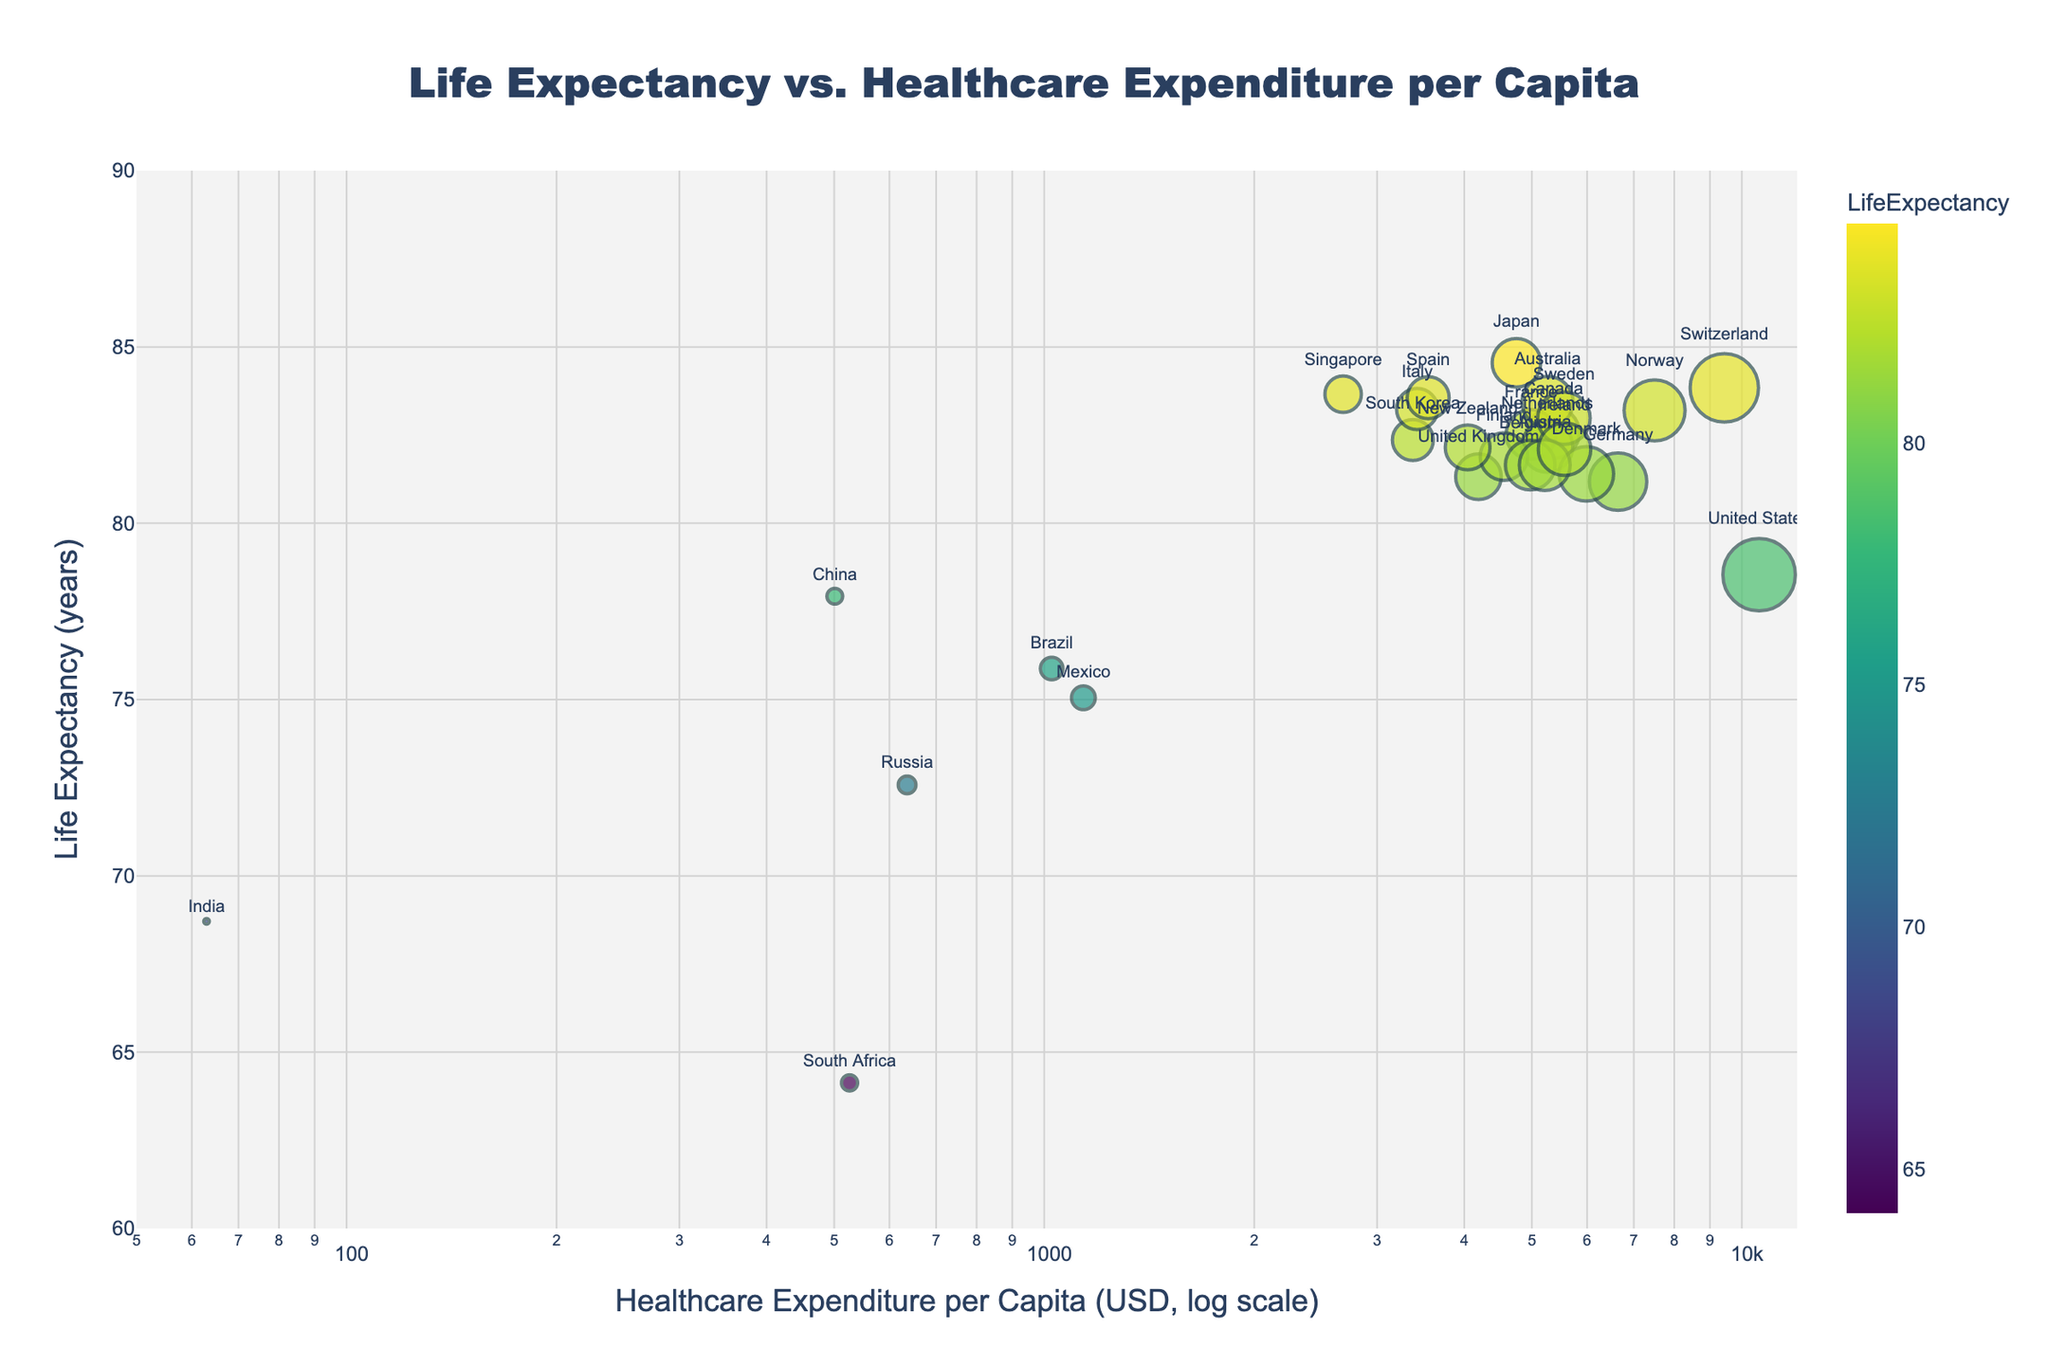what is the title of the scatter plot? The title of a plot is usually found at the top and it summarizes what the graph is about. Looking at the top of the scatter plot, the title reads "Life Expectancy vs. Healthcare Expenditure per Capita"
Answer: Life Expectancy vs. Healthcare Expenditure per Capita How many countries have a life expectancy above 80 years? To answer this, we need to count the number of data points (bubbles) on the scatter plot where the y-axis value (life expectancy) is above 80. By observation, there are 21 countries with life expectancy above 80 years.
Answer: 21 Which country has the highest healthcare expenditure per capita? To answer this, we need to look for the right-most data point (bubble) since the x-axis represents healthcare expenditure per capita on a log scale. The United States is the right-most point, indicating it has the highest healthcare expenditure per capita.
Answer: United States Among countries with healthcare expenditure per capita less than $1,000, which country has the highest life expectancy? First, locate the data points to the left of $1,000 on the x-axis (healthcare expenditure per capita). Among these points, identify the one with the highest y-axis value (life expectancy). South Africa, with a healthcare expenditure per capita of $526 and a life expectancy of 64.13, stands out in this range.
Answer: South Africa What is the difference in life expectancy between Japan and the United States? To find the difference, subtract the life expectancy of the United States from that of Japan. Japan's life expectancy is 84.55 years, and the United States' life expectancy is 78.54 years. 84.55 - 78.54 = 6.01 years.
Answer: 6.01 years Do higher healthcare expenditures always correlate to higher life expectancies? Give an example to support your answer. Generally, higher healthcare expenditures tend to correlate with higher life expectancies, but there are exceptions. For instance, the United States spends the most on healthcare per capita yet only has a life expectancy of 78.54 years, whereas Japan has a life expectancy of 84.55 years with significantly lower expenditure.
Answer: No, for example, the United States and Japan Which country has the lowest healthcare expenditure per capita, and what is its life expectancy? Look for the left-most data point (bubble) on the scatter plot because the x-axis represents healthcare expenditure per capita on a log scale. India is the left-most point with healthcare expenditure per capita of $63 and a life expectancy of 68.71 years.
Answer: India, 68.71 years Compare the life expectancy of Canada and Germany. Which country has a higher life expectancy and by how much? Observe the y-axis values for Canada and Germany. Canada has a life expectancy of 82.57 years, while Germany has a life expectancy of 81.18 years. The difference is 82.57 - 81.18 = 1.39 years.
Answer: Canada, by 1.39 years What observation can you make about the cluster of countries with life expectancy between 81 to 84 years and healthcare expenditure per capita between $4,000 and $6,000? Identify the cluster in the specified ranges on the scatter plot. This cluster indicates a group of countries where despite similar ranges of healthcare spending, the life expectancy is relatively high and clustered closely together, suggesting efficient healthcare systems, e.g., the Netherlands, Sweden, the United Kingdom, and Germany.
Answer: These countries have high life expectancy with moderate healthcare expenditure per capita, indicating efficiency What patterns or trends can you determine from the distribution of countries around the logarithmic x-axis? With the log scale on the x-axis (healthcare expenditure per capita), countries with lower spending are more tightly clustered due to the higher density on the lower end of the scale, while countries with higher spending are more spread out, showing a generally positive but non-linear relationship between healthcare expenditure and life expectancy.
Answer: Higher expenditure generally correlates with higher life expectancy but not always linearly 